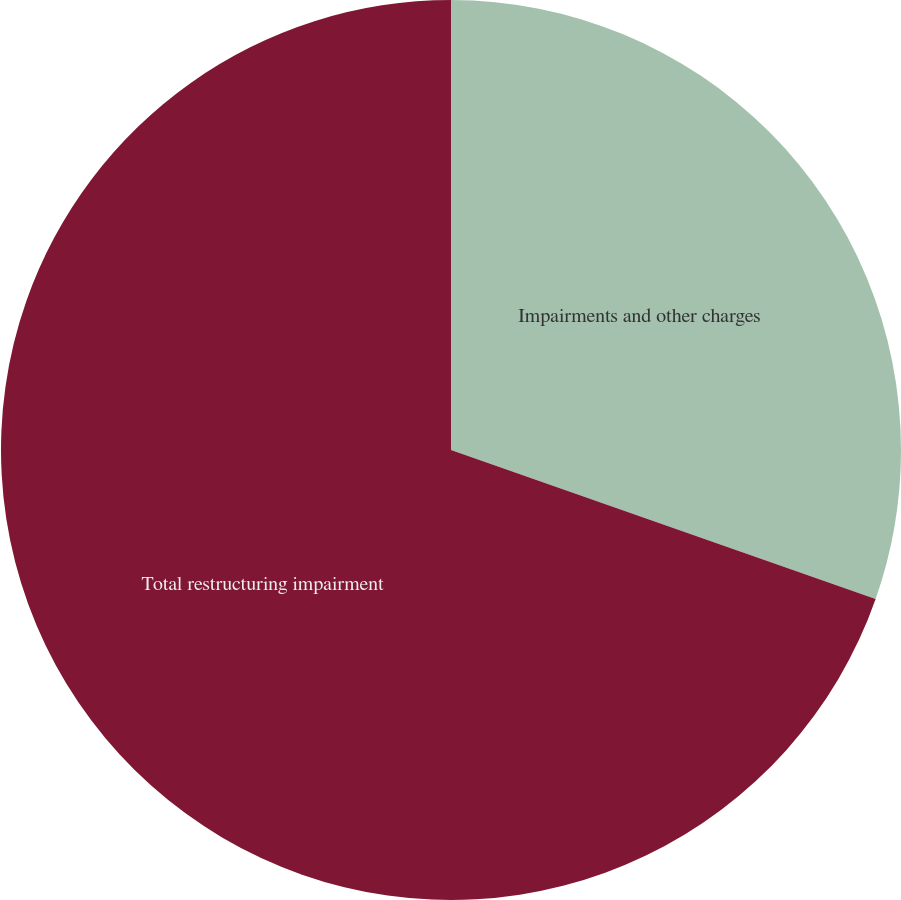Convert chart to OTSL. <chart><loc_0><loc_0><loc_500><loc_500><pie_chart><fcel>Impairments and other charges<fcel>Total restructuring impairment<nl><fcel>30.37%<fcel>69.63%<nl></chart> 